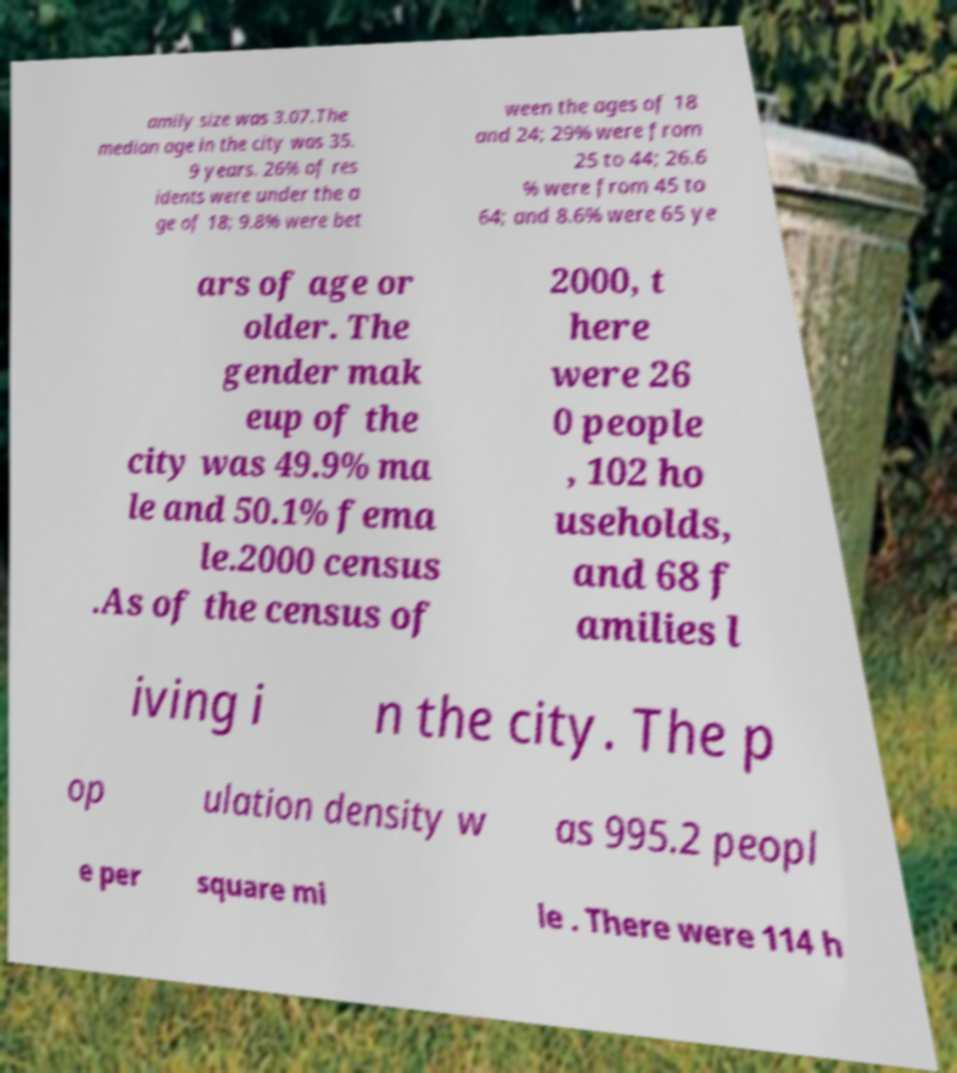Can you accurately transcribe the text from the provided image for me? amily size was 3.07.The median age in the city was 35. 9 years. 26% of res idents were under the a ge of 18; 9.8% were bet ween the ages of 18 and 24; 29% were from 25 to 44; 26.6 % were from 45 to 64; and 8.6% were 65 ye ars of age or older. The gender mak eup of the city was 49.9% ma le and 50.1% fema le.2000 census .As of the census of 2000, t here were 26 0 people , 102 ho useholds, and 68 f amilies l iving i n the city. The p op ulation density w as 995.2 peopl e per square mi le . There were 114 h 